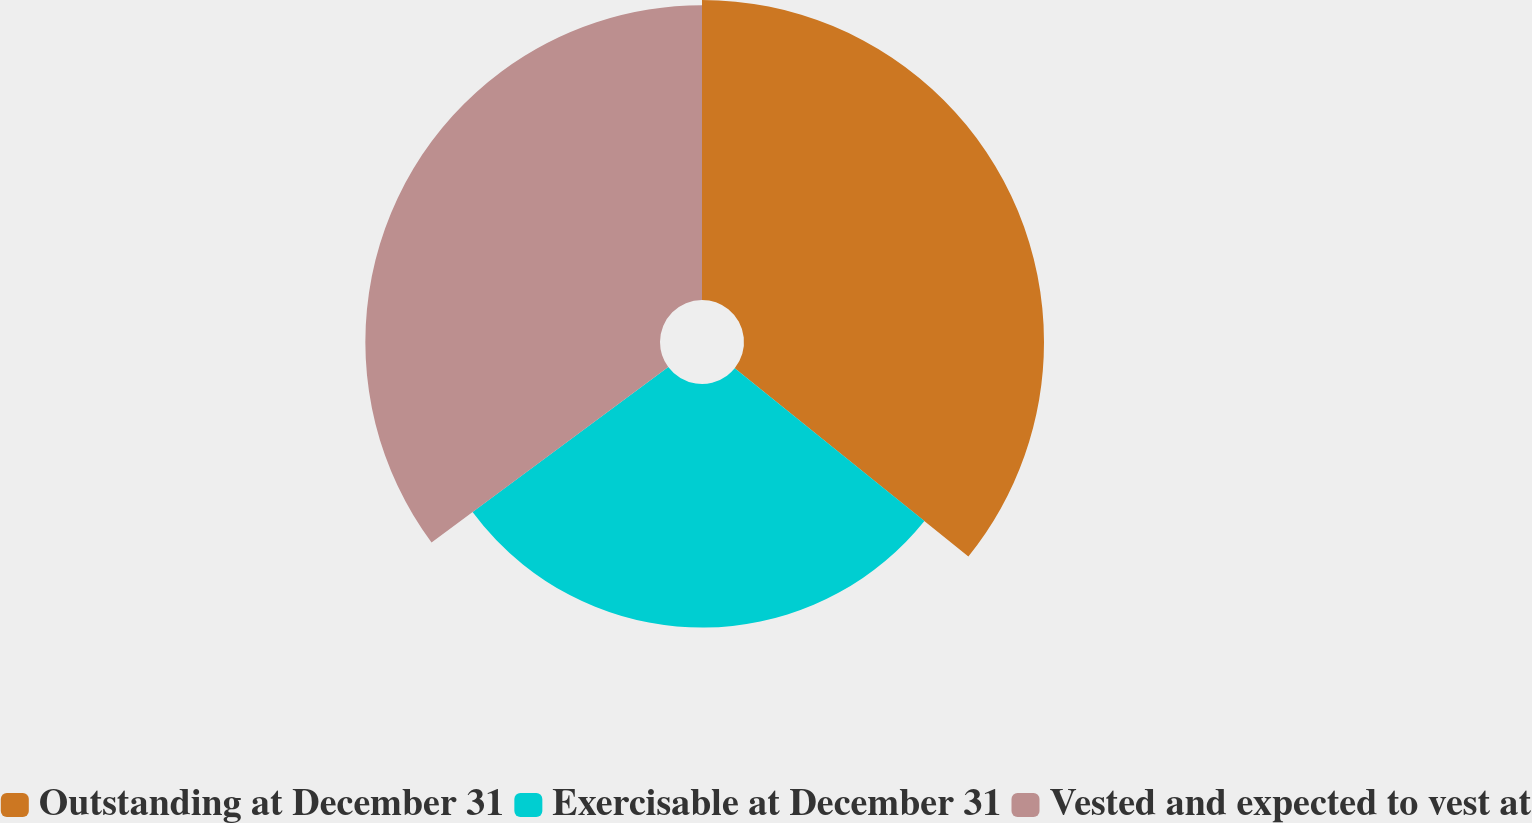<chart> <loc_0><loc_0><loc_500><loc_500><pie_chart><fcel>Outstanding at December 31<fcel>Exercisable at December 31<fcel>Vested and expected to vest at<nl><fcel>35.79%<fcel>29.06%<fcel>35.15%<nl></chart> 